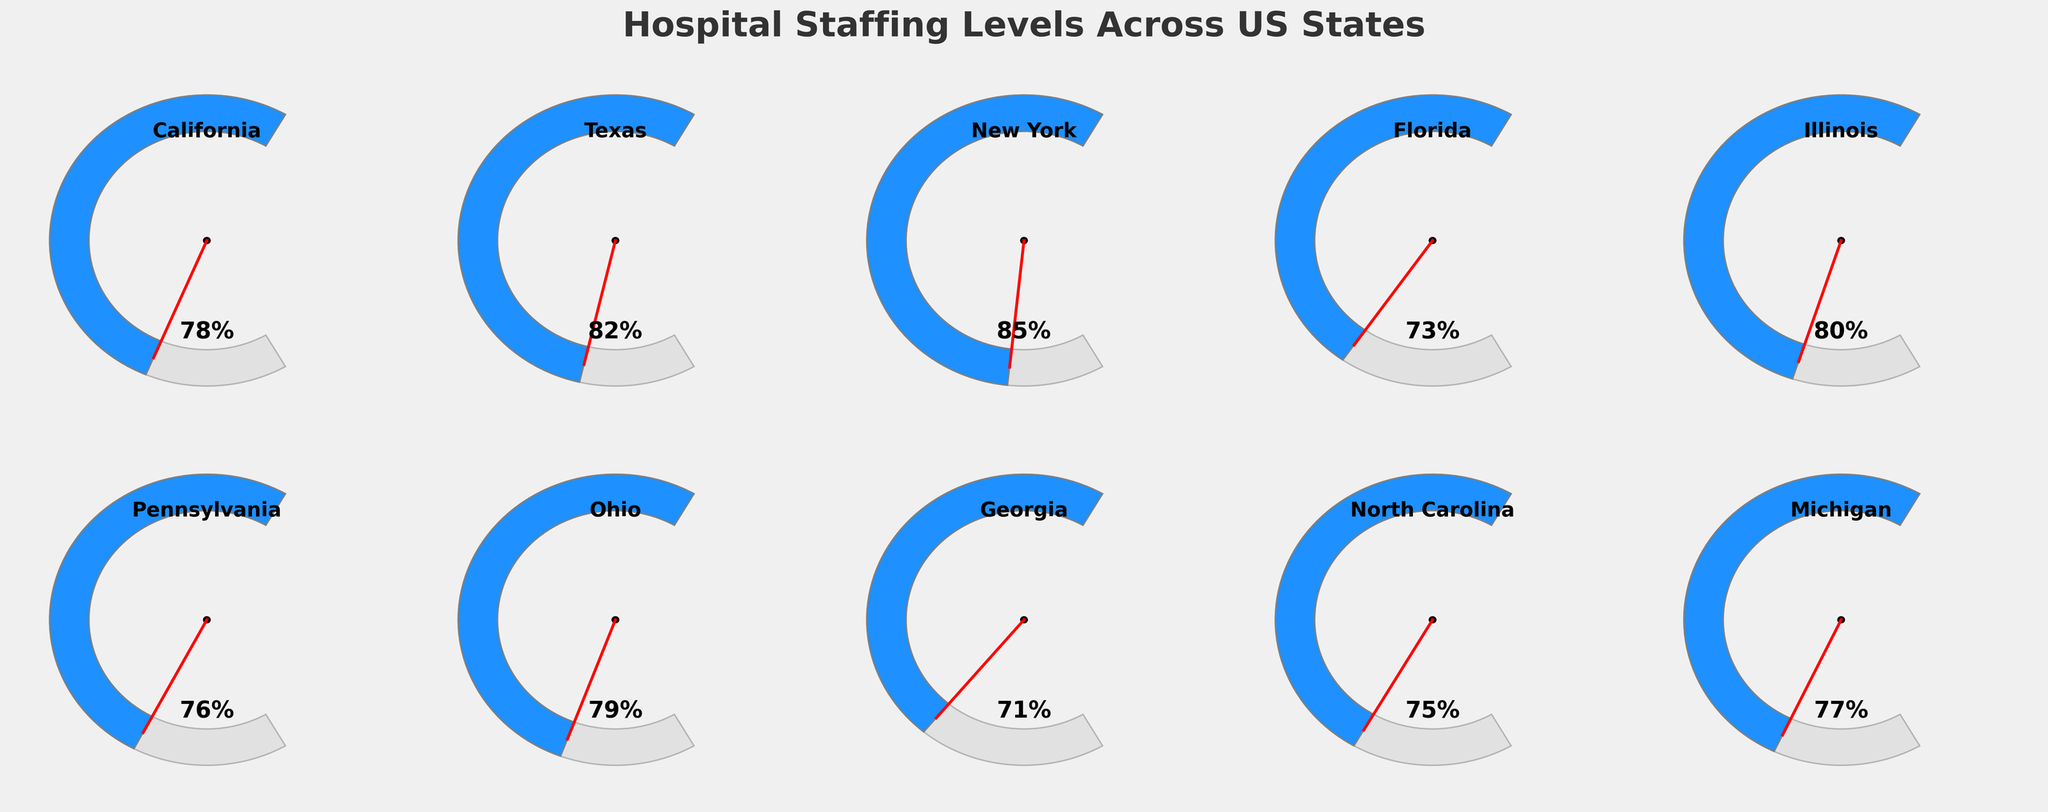Which state has the highest hospital staffing level? New York shows 85% on its gauge chart, which is the highest staffing level among the states listed.
Answer: New York Which state has the lowest hospital staffing level? Georgia shows 71% on its gauge chart, which is the lowest staffing level among the states listed.
Answer: Georgia How does California's staffing level compare to Illinois's? California has a staffing level of 78%, while Illinois has 80%. Since 80% is higher, Illinois has a slightly better staffing level than California.
Answer: Illinois is higher What's the average staffing level across all the states? To calculate the average staffing level: (78 + 82 + 85 + 73 + 80 + 76 + 79 + 71 + 75 + 77) / 10 = 776 / 10 = 77.6%. Thus, the average staffing level is 77.6%.
Answer: 77.6% Which states have a staffing level greater than 80%? The gauge charts show that Texas (82%) and New York (85%) have staffing levels greater than 80%.
Answer: Texas, New York What is the median staffing level of the states presented? To find the median, we first list the staffing levels in ascending order: 71, 73, 75, 76, 77, 78, 79, 80, 82, 85. The middle values are 77 and 78, so the median is (77 + 78) / 2 = 77.5%.
Answer: 77.5% Which state has a staffing level closest to the national average? The national average is 77.6%. Michigan has a staffing level of 77%, which is closest to the national average.
Answer: Michigan What is the range of the staffing levels among the states? The range is the difference between the maximum and minimum values. The highest staffing level is 85% (New York) and the lowest is 71% (Georgia). The range is 85 - 71 = 14%.
Answer: 14% How many states have a staffing level below 75%? The gauge charts show that Florida (73%) and Georgia (71%) have staffing levels below 75%. Counting these, we have 2 states.
Answer: 2 What is the difference between the staffing levels of the states with the highest and lowest values? The highest staffing level is in New York (85%) and the lowest is in Georgia (71%). The difference is 85 - 71 = 14%.
Answer: 14% 